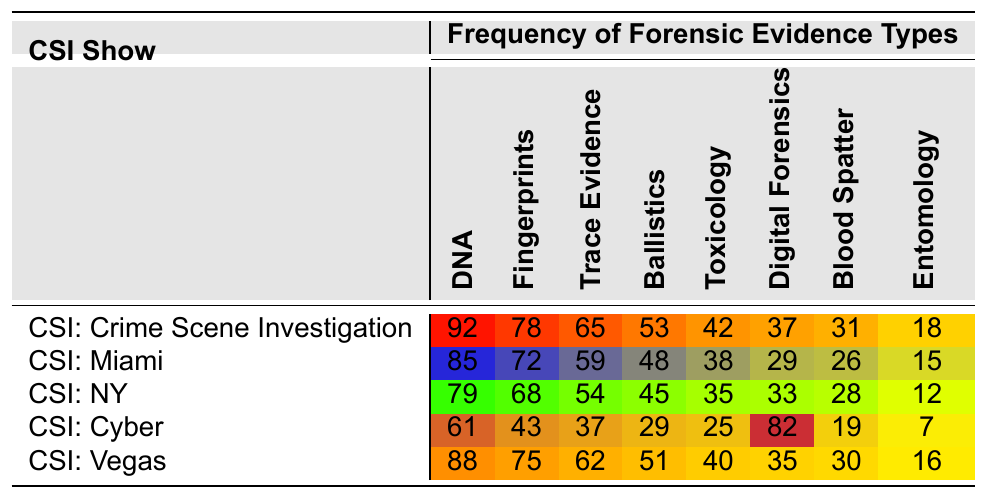What is the highest frequency of DNA evidence found in a single show? The highest frequency of DNA evidence in the table is found in "CSI: Crime Scene Investigation" with a value of 92.
Answer: 92 Which show has the lowest frequency of Blood Spatter evidence? Looking through the Blood Spatter column, "CSI: Cyber" has the lowest frequency with a value of 7.
Answer: 7 What is the average frequency of Fingerprints across all shows? The Fingerprints frequencies are 78, 72, 68, 43, and 75. Their sum is 336. There are 5 shows, so the average is 336 / 5 = 67.2.
Answer: 67.2 Which evidence type appears most frequently in "CSI: Miami"? In "CSI: Miami", the evidence type with the highest frequency is DNA, with a count of 85.
Answer: DNA Is the frequency of Toxicology evidence more than 30 in all CSI shows? Checking the Toxicology frequencies, they are 42, 38, 35, 25, and 40. The frequency is not more than 30 in "CSI: Cyber," which has 25.
Answer: No What is the difference in frequency of Trace Evidence between "CSI: Vegas" and "CSI: NY"? The frequencies for Trace Evidence are 62 for "CSI: Vegas" and 54 for "CSI: NY." The difference is 62 - 54 = 8.
Answer: 8 What is the total frequency of Digital Forensics evidence in "CSI: Crime Scene Investigation" and "CSI: NY"? The frequencies for Digital Forensics in these shows are 37 (CSI: Crime Scene Investigation) and 33 (CSI: NY). Their total is 37 + 33 = 70.
Answer: 70 Which show uses the least amount of Entomology evidence? The Entomology frequency in "CSI: Cyber" is lowest at 7.
Answer: 7 What is the median frequency of Ballistics evidence across all shows? The Ballistics frequencies are 53, 48, 45, 29, and 51. When arranged in order (29, 45, 48, 51, 53), the median frequency is the middle value, which is 48.
Answer: 48 Are there any shows where the frequency of Toxicology evidence exceeds the frequency of trace evidence? For "CSI: Crime Scene Investigation" (Toxicology 42, Trace 65), "CSI: Miami" (Toxicology 38, Trace 59), and "CSI: NY" (Toxicology 35, Trace 54), Toxicology does not exceed Trace. However, for "CSI: Cyber" (Toxicology 25, Trace 37) and "CSI: Vegas" (Toxicology 40, Trace 62), it remains lower.
Answer: No 